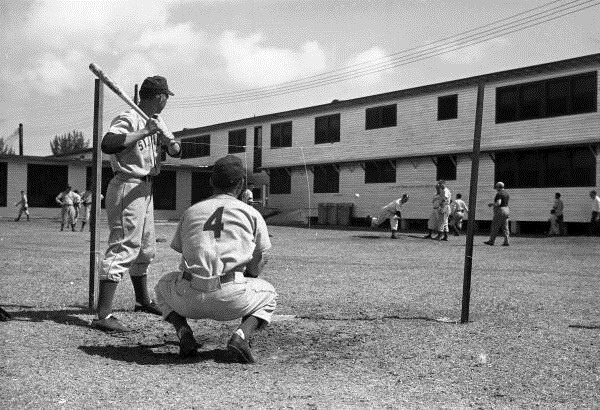Describe the objects in this image and their specific colors. I can see people in darkgray, gray, lightgray, and black tones, people in darkgray, gray, black, and lightgray tones, people in darkgray, black, gray, and lightgray tones, people in darkgray, gray, black, and lightgray tones, and people in darkgray, gray, black, and lightgray tones in this image. 